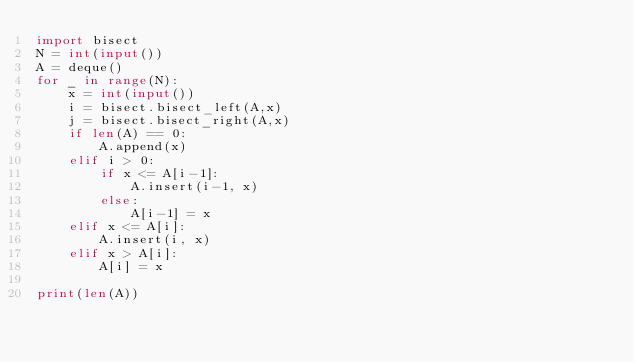Convert code to text. <code><loc_0><loc_0><loc_500><loc_500><_Python_>import bisect
N = int(input())
A = deque()
for _ in range(N):
    x = int(input())
    i = bisect.bisect_left(A,x)
    j = bisect.bisect_right(A,x)
    if len(A) == 0:
        A.append(x)
    elif i > 0:
        if x <= A[i-1]:
            A.insert(i-1, x)
        else:
            A[i-1] = x
    elif x <= A[i]:
        A.insert(i, x)
    elif x > A[i]:
        A[i] = x

print(len(A))</code> 